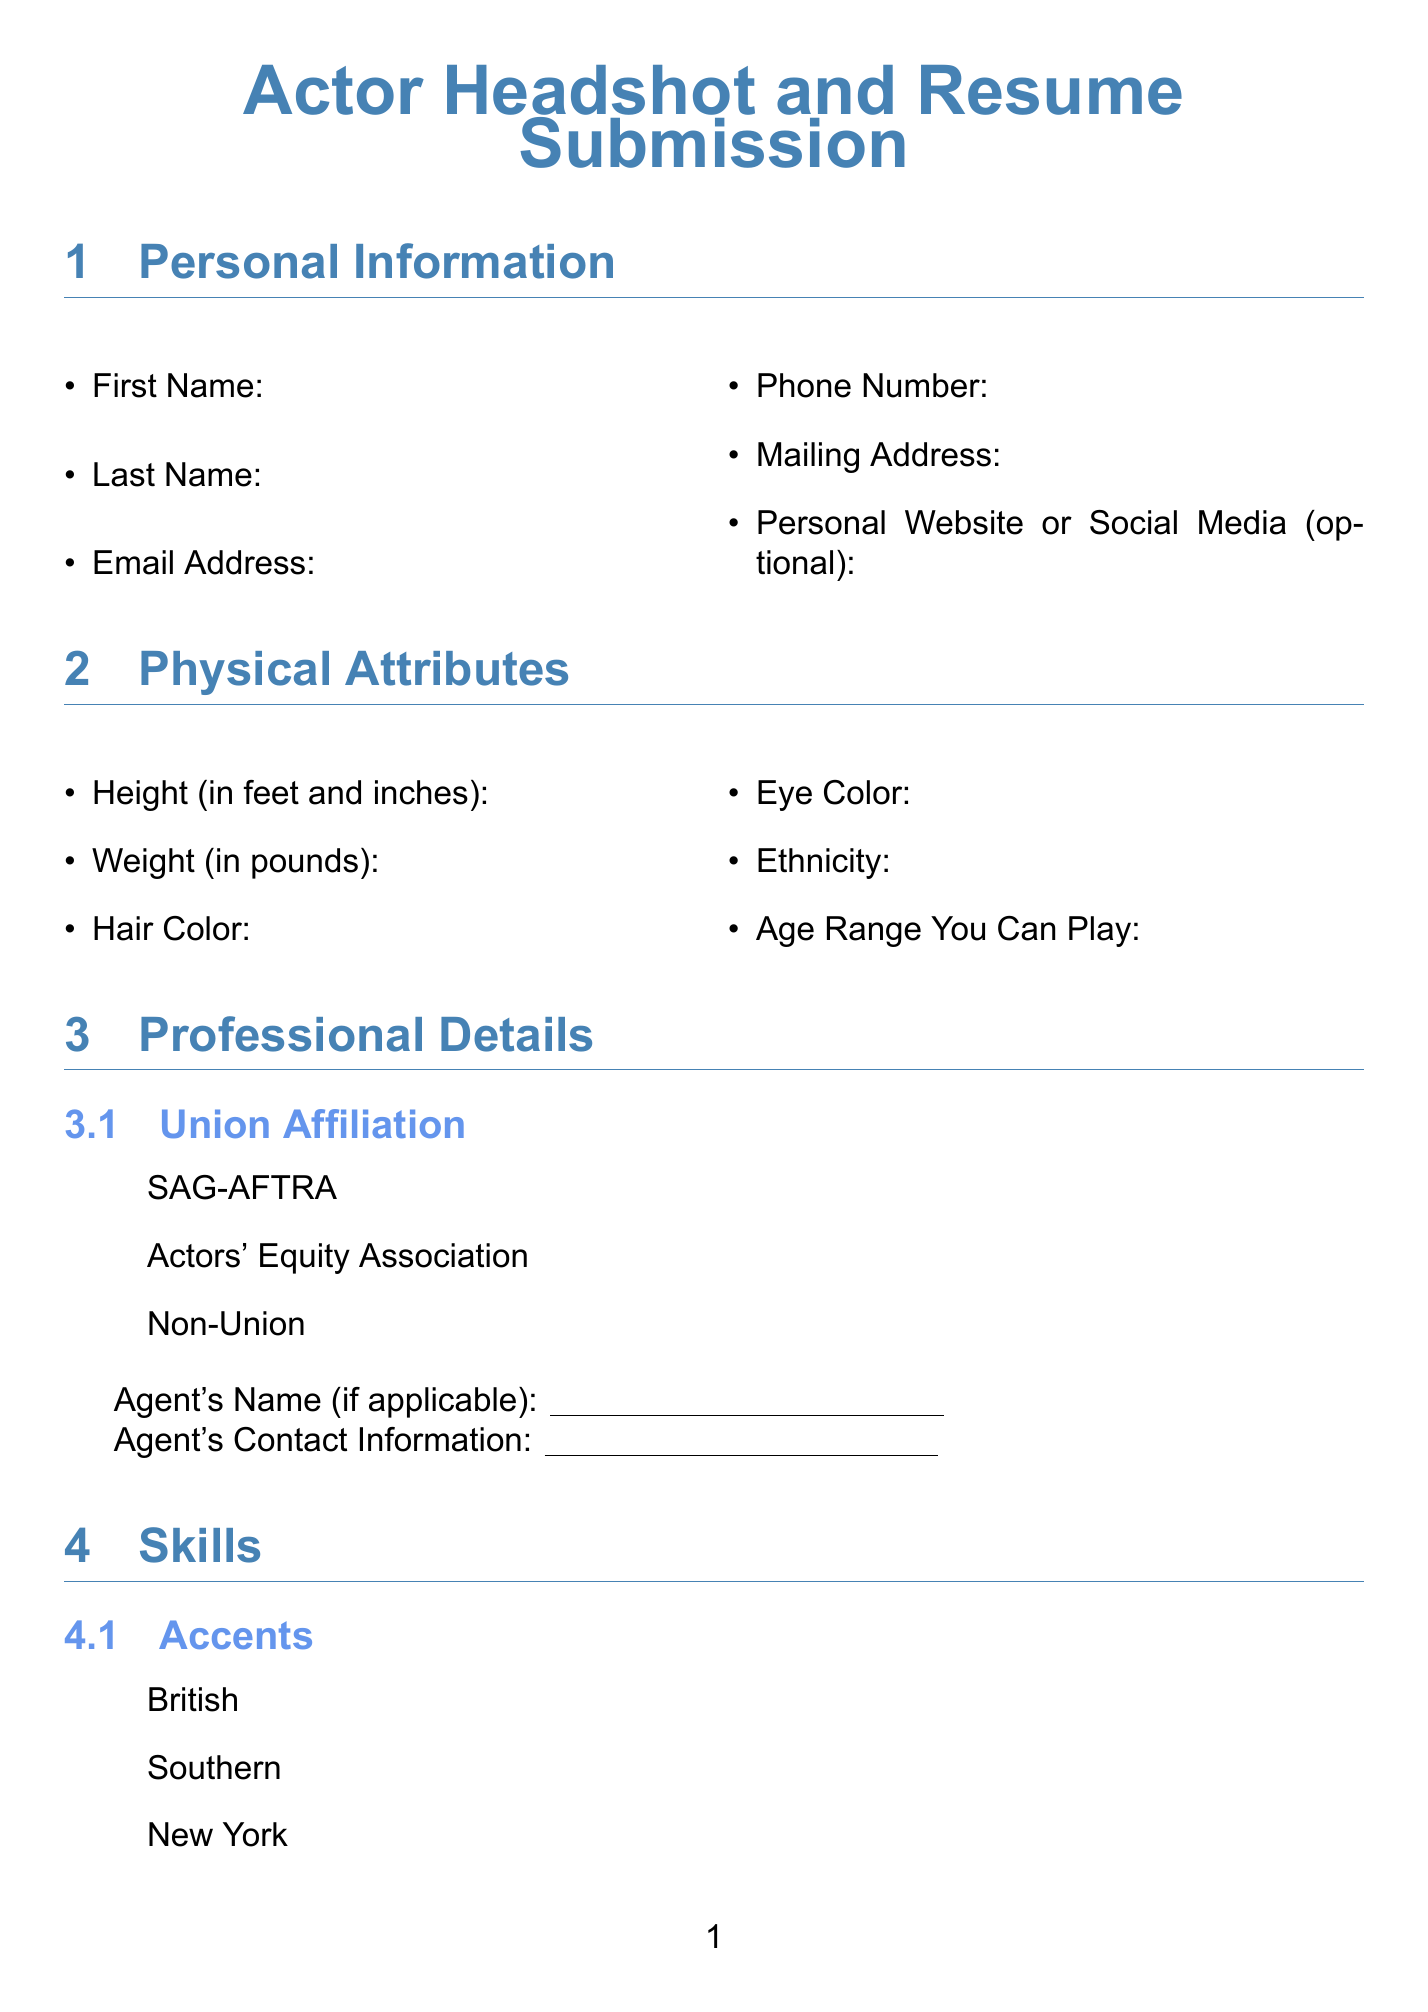what is the title of the form? The title of the form is stated at the beginning, which is "Actor Headshot and Resume Submission."
Answer: Actor Headshot and Resume Submission what is the email address field labeled as? The email address section of the personal information part is labeled "Email Address."
Answer: Email Address how many accents can be selected? The skills section provides six options for accents, which can be selected by the applicant.
Answer: Six what information is required for the agent section? The agent section requires the applicant to fill in the name and contact information of their agent if applicable.
Answer: Agent's Name and Agent's Contact Information which year should be filled in for education? The applicant needs to indicate the year they graduated from their acting school or university in the education section.
Answer: Year of Graduation what are the required formats for the headshot upload? The document specifies that acceptable formats for headshot uploads are .jpg, .png, and .tiff.
Answer: .jpg, .png, .tiff how did the applicants hear about the virtual workshops? Applicants are asked to specify how they discovered the workshops in the additional information section.
Answer: How did you hear about our virtual workshops? are there options for special skills in the form? Yes, the special skills section lists multiple options for talents that applicants can indicate they possess.
Answer: Yes 